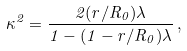Convert formula to latex. <formula><loc_0><loc_0><loc_500><loc_500>\kappa ^ { 2 } = \frac { 2 ( r / R _ { 0 } ) \lambda } { 1 - ( 1 - r / R _ { 0 } ) \lambda } \, ,</formula> 